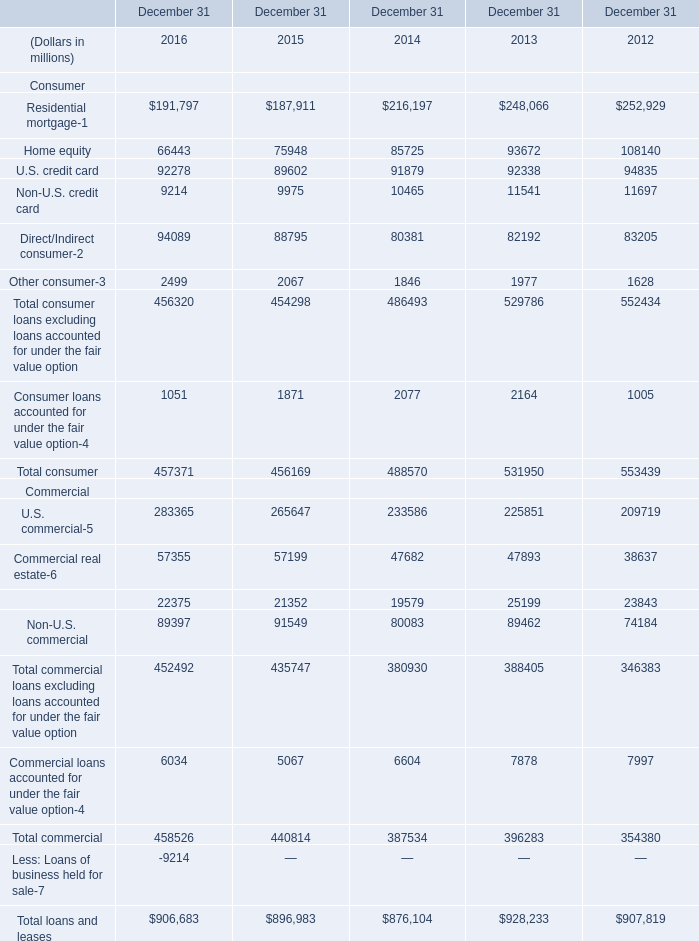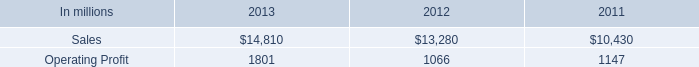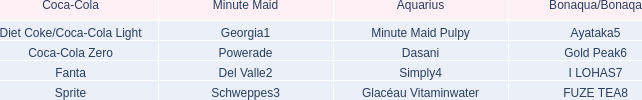What is the total amount of Commercial lease financing Commercial of December 31 2013, Operating Profit of 2012, and Commercial loans accounted for under the fair value option Commercial of December 31 2012 ? 
Computations: ((25199.0 + 1066.0) + 7997.0)
Answer: 34262.0. 